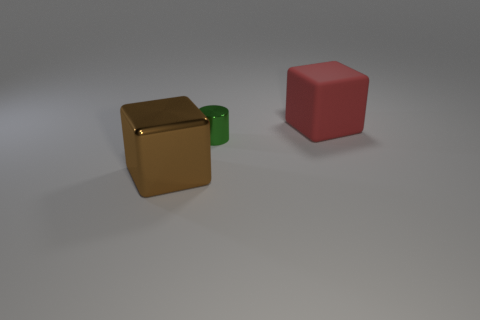The tiny cylinder has what color?
Give a very brief answer. Green. Are there any small metal cylinders in front of the brown metallic cube?
Your answer should be very brief. No. Is the shape of the matte object the same as the large object that is to the left of the large red matte cube?
Keep it short and to the point. Yes. What number of other objects are the same material as the small object?
Ensure brevity in your answer.  1. The big thing in front of the large block that is right of the big block in front of the red cube is what color?
Make the answer very short. Brown. The big object right of the block in front of the tiny object is what shape?
Keep it short and to the point. Cube. Is the number of tiny objects in front of the large red rubber cube greater than the number of yellow rubber spheres?
Your answer should be compact. Yes. There is a big rubber thing behind the large brown metallic object; does it have the same shape as the green thing?
Offer a terse response. No. Is there another large object of the same shape as the green object?
Provide a succinct answer. No. What number of things are either big cubes to the left of the red rubber block or tiny red objects?
Keep it short and to the point. 1. 